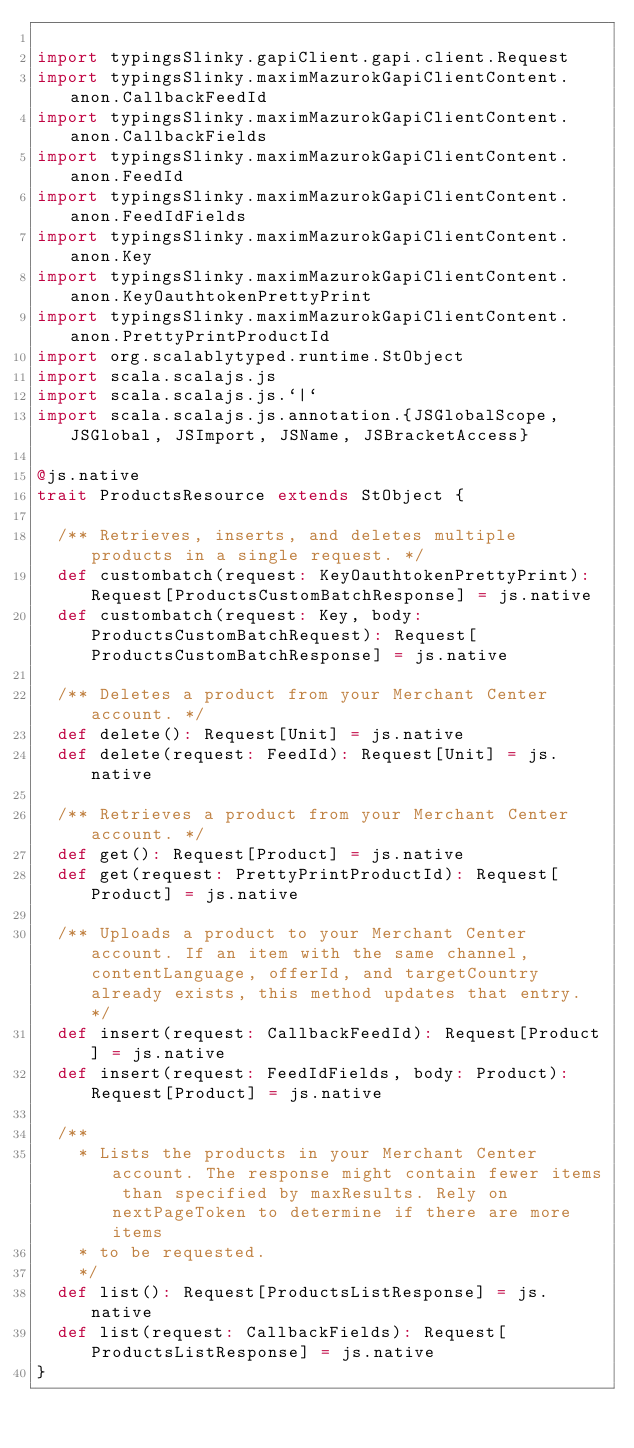Convert code to text. <code><loc_0><loc_0><loc_500><loc_500><_Scala_>
import typingsSlinky.gapiClient.gapi.client.Request
import typingsSlinky.maximMazurokGapiClientContent.anon.CallbackFeedId
import typingsSlinky.maximMazurokGapiClientContent.anon.CallbackFields
import typingsSlinky.maximMazurokGapiClientContent.anon.FeedId
import typingsSlinky.maximMazurokGapiClientContent.anon.FeedIdFields
import typingsSlinky.maximMazurokGapiClientContent.anon.Key
import typingsSlinky.maximMazurokGapiClientContent.anon.KeyOauthtokenPrettyPrint
import typingsSlinky.maximMazurokGapiClientContent.anon.PrettyPrintProductId
import org.scalablytyped.runtime.StObject
import scala.scalajs.js
import scala.scalajs.js.`|`
import scala.scalajs.js.annotation.{JSGlobalScope, JSGlobal, JSImport, JSName, JSBracketAccess}

@js.native
trait ProductsResource extends StObject {
  
  /** Retrieves, inserts, and deletes multiple products in a single request. */
  def custombatch(request: KeyOauthtokenPrettyPrint): Request[ProductsCustomBatchResponse] = js.native
  def custombatch(request: Key, body: ProductsCustomBatchRequest): Request[ProductsCustomBatchResponse] = js.native
  
  /** Deletes a product from your Merchant Center account. */
  def delete(): Request[Unit] = js.native
  def delete(request: FeedId): Request[Unit] = js.native
  
  /** Retrieves a product from your Merchant Center account. */
  def get(): Request[Product] = js.native
  def get(request: PrettyPrintProductId): Request[Product] = js.native
  
  /** Uploads a product to your Merchant Center account. If an item with the same channel, contentLanguage, offerId, and targetCountry already exists, this method updates that entry. */
  def insert(request: CallbackFeedId): Request[Product] = js.native
  def insert(request: FeedIdFields, body: Product): Request[Product] = js.native
  
  /**
    * Lists the products in your Merchant Center account. The response might contain fewer items than specified by maxResults. Rely on nextPageToken to determine if there are more items
    * to be requested.
    */
  def list(): Request[ProductsListResponse] = js.native
  def list(request: CallbackFields): Request[ProductsListResponse] = js.native
}
</code> 